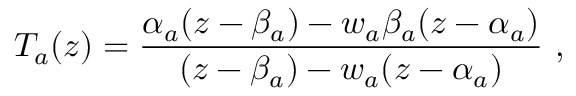<formula> <loc_0><loc_0><loc_500><loc_500>T _ { a } ( z ) = \frac { \alpha _ { a } ( z - \beta _ { a } ) - w _ { a } \beta _ { a } ( z - \alpha _ { a } ) } { ( z - \beta _ { a } ) - w _ { a } ( z - \alpha _ { a } ) } \ ,</formula> 